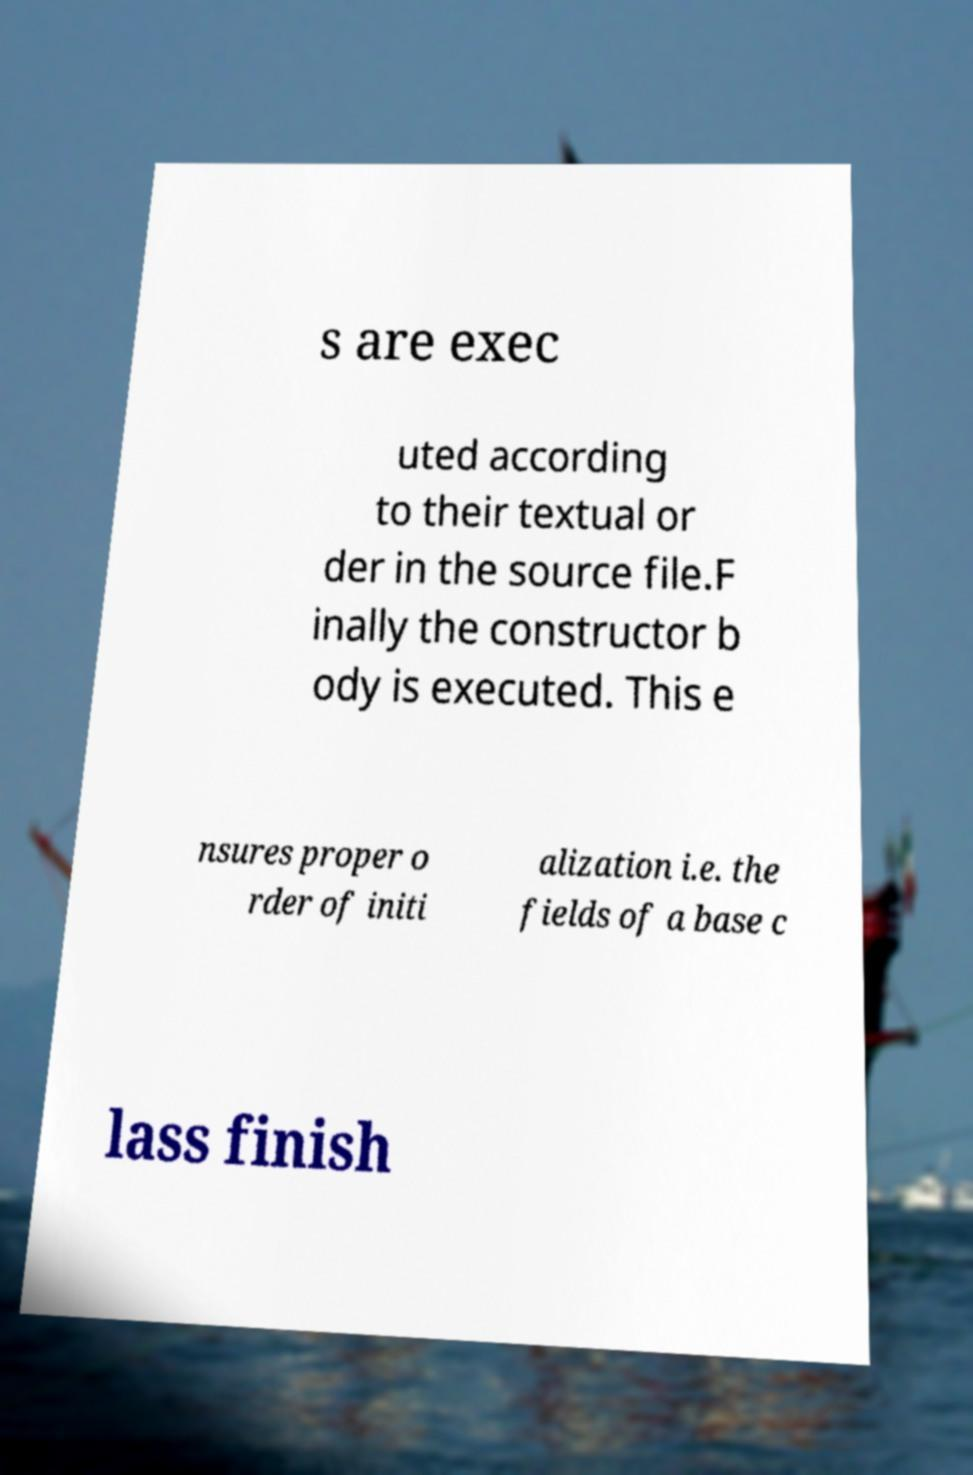Please read and relay the text visible in this image. What does it say? s are exec uted according to their textual or der in the source file.F inally the constructor b ody is executed. This e nsures proper o rder of initi alization i.e. the fields of a base c lass finish 